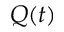<formula> <loc_0><loc_0><loc_500><loc_500>Q ( t )</formula> 